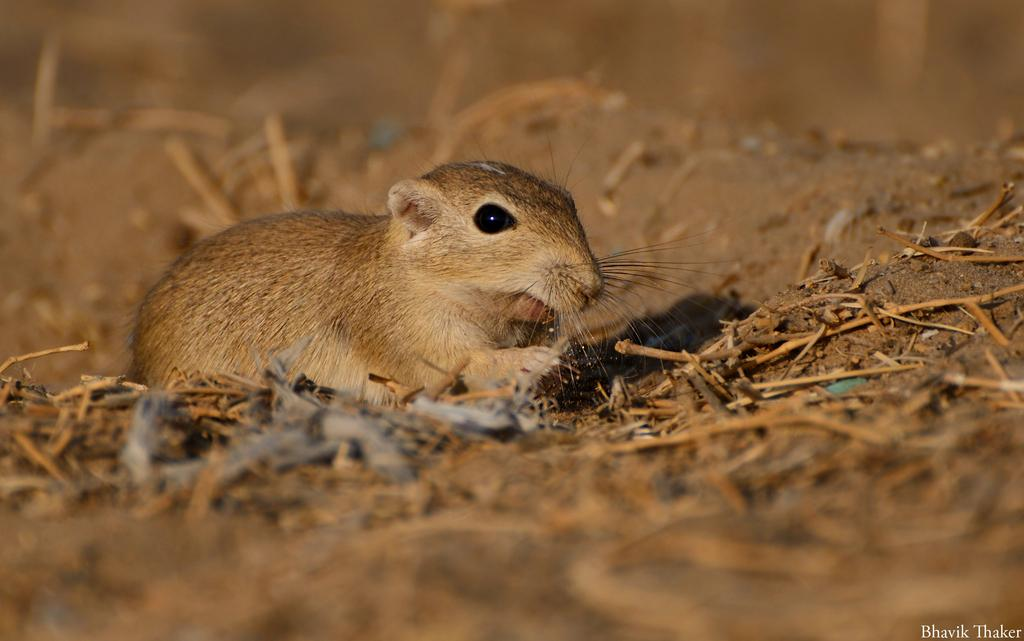What type of animal is in the image? There is a mouse in the image. What color is the mouse? The mouse is brown in color. Where is the mouse located in the image? The mouse is on the ground. What else can be seen on the ground in the image? There are sticks on the ground in the image. Can you describe the background of the image? The background of the image is blurred. Is the mouse shaking a glass during a rainstorm in the image? No, there is no glass or rainstorm present in the image. The image features a brown mouse on the ground with sticks nearby, and the background is blurred. 